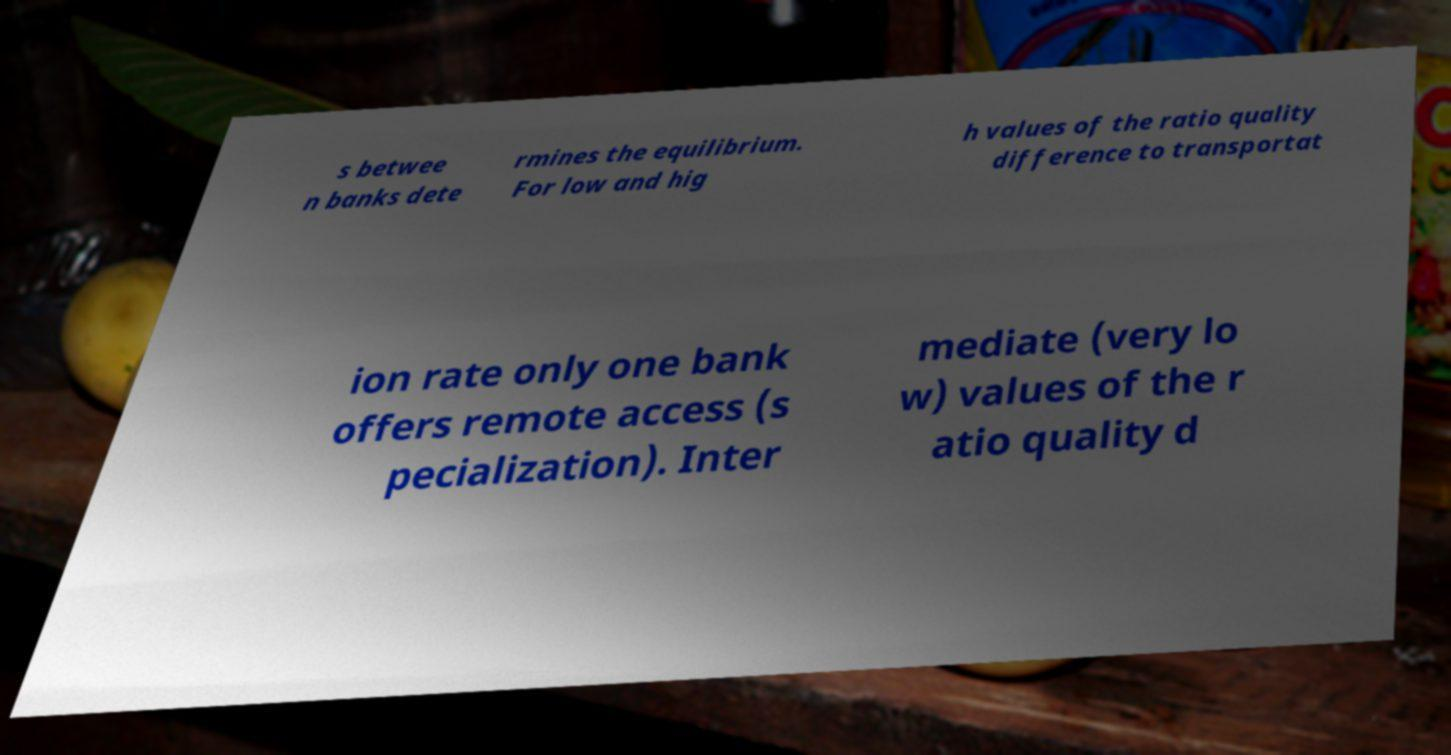Could you assist in decoding the text presented in this image and type it out clearly? s betwee n banks dete rmines the equilibrium. For low and hig h values of the ratio quality difference to transportat ion rate only one bank offers remote access (s pecialization). Inter mediate (very lo w) values of the r atio quality d 